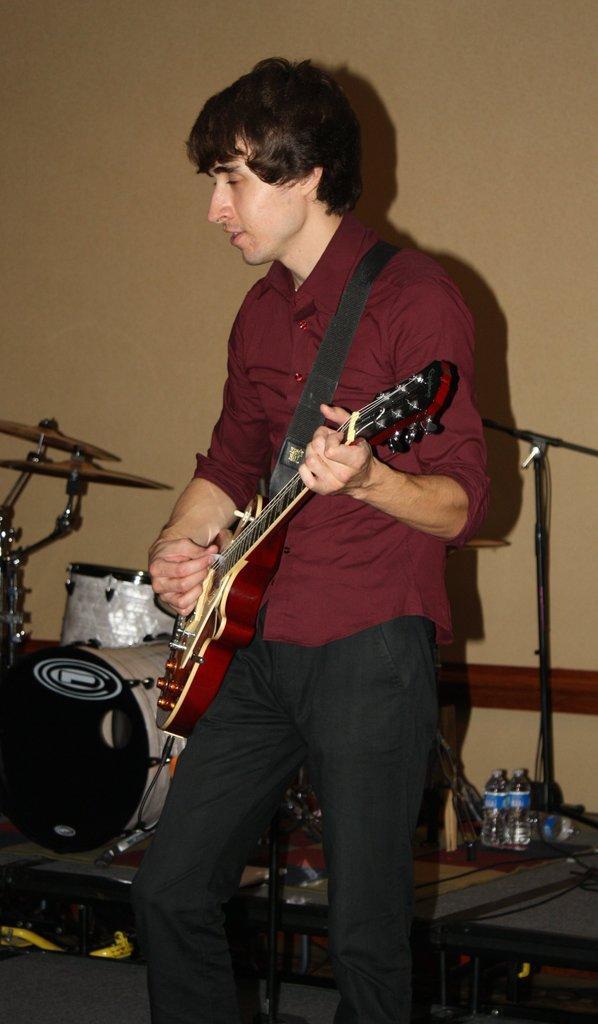Could you give a brief overview of what you see in this image? In this picture we can see a man in red shirt and black pant holding a guitar and playing it behind him there is a desk on which there are some musical instruments in some bottles on it. 